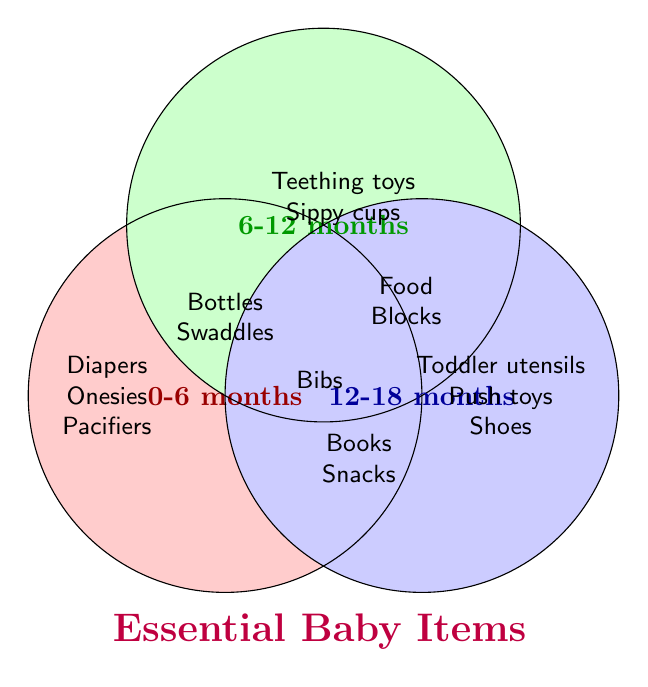What age range is represented by the red circle? The red circle is labeled "0-6 months," indicating that it represents items for infants aged 0-6 months.
Answer: 0-6 months What items are shared between the 0-6 months and 6-12 months age ranges? The items in the overlapping section of the red and green circles are Baby bottles, Swaddle blankets, and Bibs.
Answer: Baby bottles, Swaddle blankets, Bibs What essential baby items are unique to the 12-18 months age range? The blue circle labeled "12-18 months" contains items unique to this age range, including Toddler utensils, Push-and-pull toys, Sturdy shoes, Board books, Stacking cups, Crayons, Toddler snacks, Potty training seat, Toddler toothbrush, Play kitchen set.
Answer: Toddler utensils, Push-and-pull toys, Sturdy shoes, Board books, Stacking cups, Crayons, Toddler snacks, Potty training seat, Toddler toothbrush, Play kitchen set Which items are found in all three age ranges? There is no intersection among all three circles, indicating no items are shared across all three age ranges.
Answer: None Are any items specifically for the "6-12 months" age range and also found in the "12-18 months" range but not in the "0-6 months" range? The items in the overlapping section of the green circle (6-12 months) and the blue circle (12-18 months) but not in the red circle (0-6 months) are Baby food, Soft blocks, and Finger foods.
Answer: Baby food, Soft blocks, Finger foods Which age range has diapers listed as an essential item? The red circle labeled "0-6 months" includes diapers.
Answer: 0-6 months What items are common between "0-6 months" and the other two age ranges together? Items shared between "0-6 months" and either of the other two age ranges include Baby bottles, Swaddle blankets, and Bibs.
Answer: Baby bottles, Swaddle blankets, Bibs How many unique items are listed for the 6-12 months age range? There are 10 unique items for the 6-12 months age range: Teething toys, Sippy cups, Baby food, Finger foods, Baby-proofing items, Soft blocks, Crawling mats, High chair, Walker, and Bibs.
Answer: 10 What age ranges share bibs as an essential item? The overlapping section of all three circles shows that Bibs are shared between all age ranges.
Answer: All age ranges 